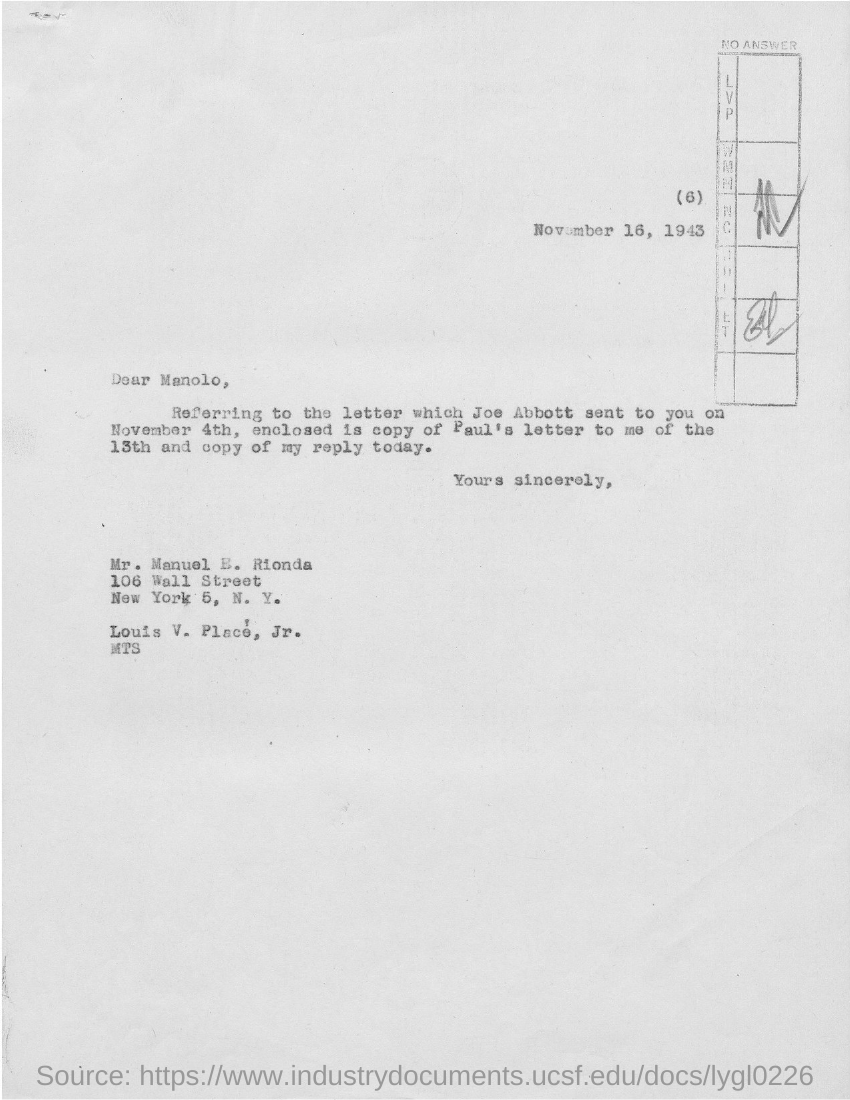Outline some significant characteristics in this image. The letter is written to Manolo. The letter is dated November 16, 1943. 